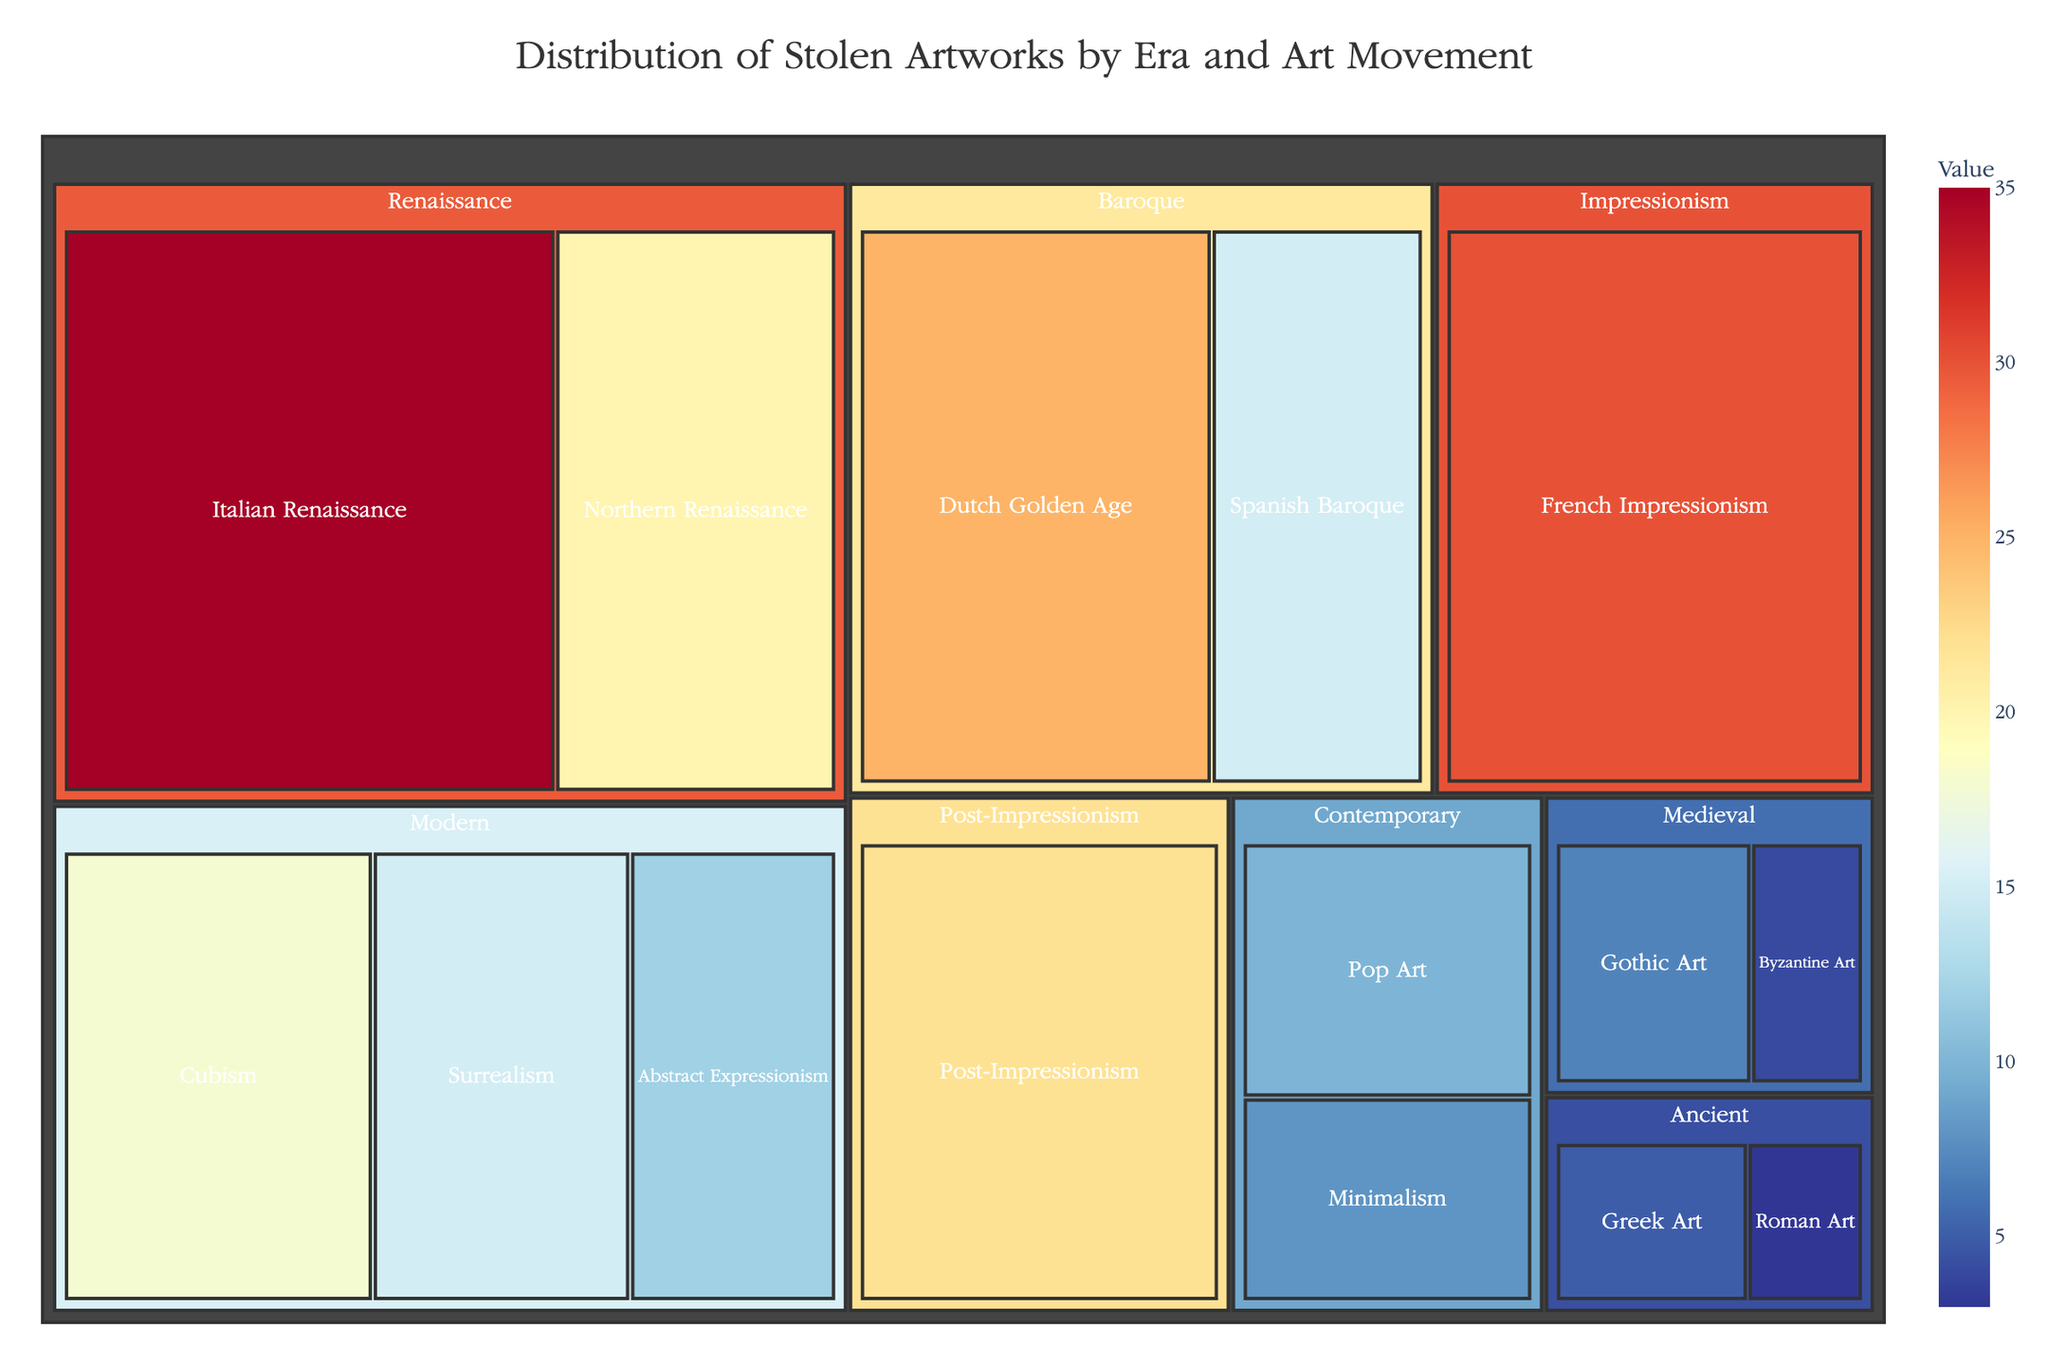What is the title of the treemap? The title of the treemap is directly mentioned at the top of the figure which helps viewers understand what the treemap is about.
Answer: Distribution of Stolen Artworks by Era and Art Movement Which era has the highest total value of stolen artworks? Look at the sections representing the different eras and find the one with the largest combined area and highest value.
Answer: Renaissance Which art movement within the Renaissance era has the higher value? Compare the values of the "Italian Renaissance" and "Northern Renaissance" sections within the Renaissance era.
Answer: Italian Renaissance What is the sum of the stolen artworks' value in the Modern era? Find the values corresponding to the movements within the Modern era and sum them up: 18 (Cubism) + 15 (Surrealism) + 12 (Abstract Expressionism).
Answer: 45 Which era has the smallest representation in terms of value? Identify the era with the smallest section and the lowest value.
Answer: Ancient Is the value of stolen French Impressionism artworks higher or lower than that of Post-Impressionism artworks? Compare the values of the "French Impressionism" and "Post-Impressionism" sections.
Answer: Higher What's the total value of stolen artworks for eras represented by less than 10 value units? Identify the eras with values less than 10 and sum them: Ancient (5 + 3), Medieval (7 + 4), and Contemporary (10 + 8).
Answer: 37 How does the value of stolen Gothic Art compare to Byzantine Art within the Medieval era? Compare the values of "Gothic Art" and "Byzantine Art" within the Medieval era.
Answer: Higher What is the average value of stolen artworks in the Baroque era? Sum the values of the movements within the Baroque era and divide by the number of movements: (25 + 15) / 2.
Answer: 20 Which art movement has the lowest value of stolen artworks? Look through all the art movements and find the one with the smallest value.
Answer: Roman Art 